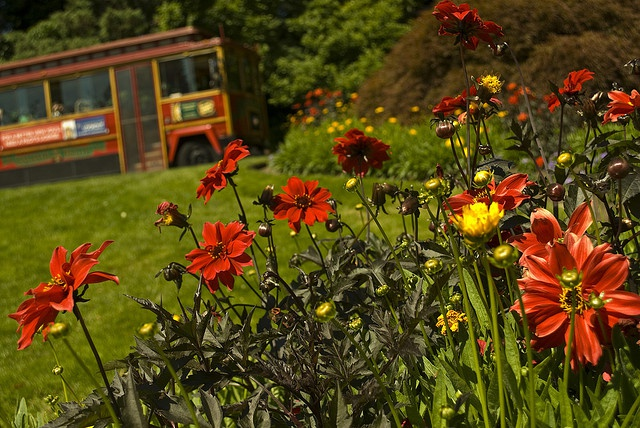Describe the objects in this image and their specific colors. I can see bus in black, olive, maroon, and brown tones and people in black, olive, and tan tones in this image. 